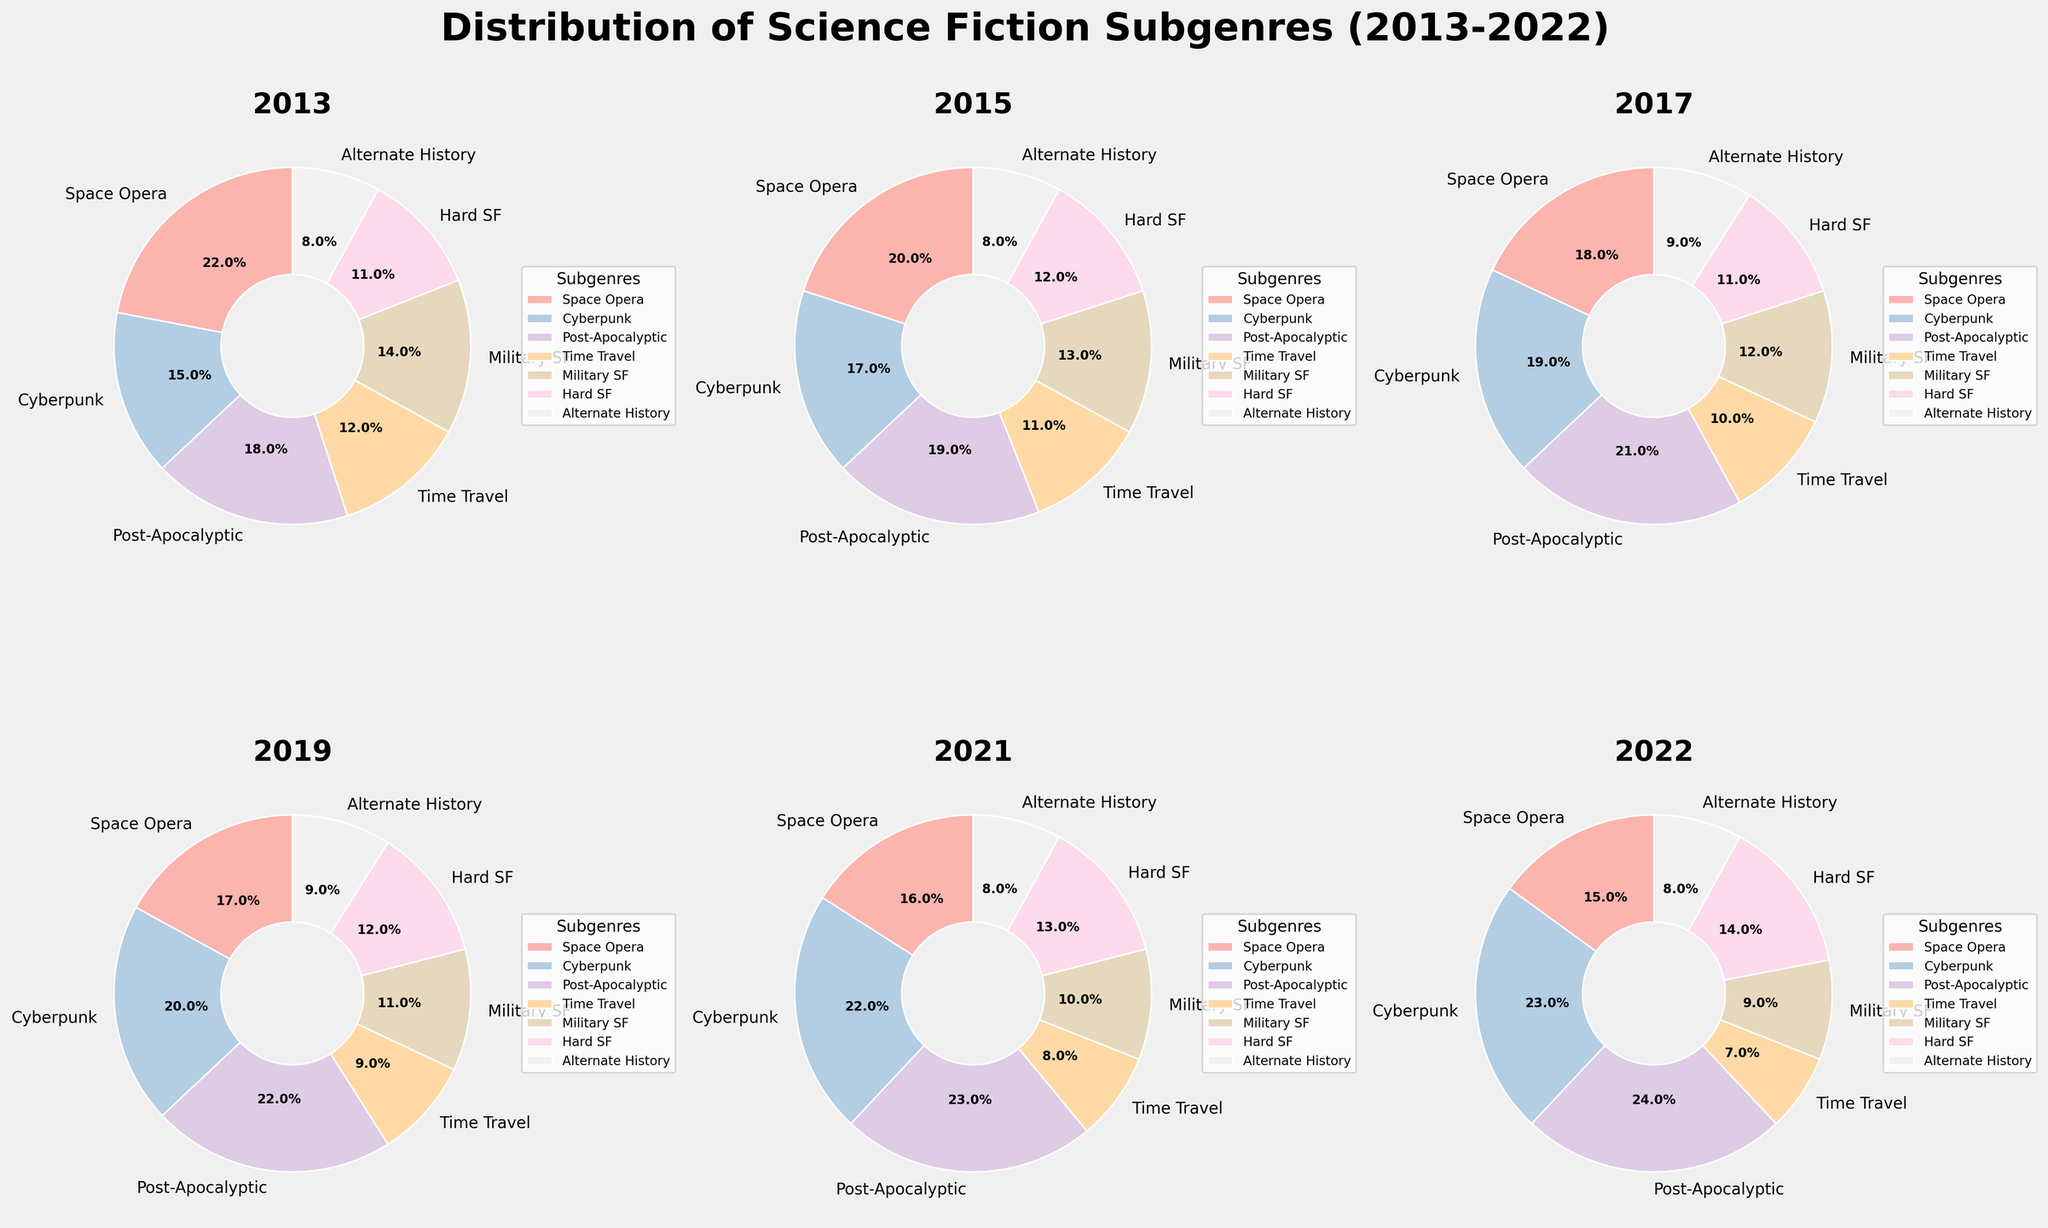What subgenre saw the highest percentage in 2022? To determine this, we look at the pie chart for the year 2022. The slice with the largest area and value is the subgenre we're looking for, which is Cyberpunk with 23%.
Answer: Cyberpunk with 23% Which subgenre's percentage increased the most from 2013 to 2022? To find this, identify the percentage of each subgenre in 2013 and 2022, and calculate the difference for each. The subgenre with the highest positive change is Cyberpunk (23% in 2022 - 15% in 2013 = 8%).
Answer: Cyberpunk with an 8% increase Did any subgenre remain at 8% throughout the given years? Inspect the pie charts for each year. Alternate History remains consistently at 8% each year: 2013, 2015, 2017, 2019, 2021, and 2022.
Answer: Alternate History Compare the trends of Space Opera and Post-Apocalyptic from 2013 to 2022. Check the percentages of Space Opera and Post-Apocalyptic for each given year: Space Opera decreases from 22% (2013) to 15% (2022), while Post-Apocalyptic increases from 18% (2013) to 24% (2022).
Answer: Space Opera decreases, Post-Apocalyptic increases Which year had the lowest percentage for Time Travel? Scan through the pie charts for each year focusing on Time Travel. The lowest percentage is 7% in 2022.
Answer: 2022 at 7% How many subgenres have a percentage of 12% or higher in any year? Count each instance where a subgenre reaches 12% or more across all years: Space Opera, Cyberpunk, Post-Apocalyptic, Military SF, Hard SF, and Time Travel.
Answer: 6 subgenres What is the combined percentage for Cyberpunk and Hard SF in 2021? Find the percentages for Cyberpunk (22%) and Hard SF (13%) in 2021 and sum them up: 22% + 13% = 35%.
Answer: 35% In which year did Post-Apocalyptic subgenre have its largest share, and what was it? Look at the percentages for Post-Apocalyptic from each pie chart. The largest percentage is in 2022 at 24%.
Answer: 2022 at 24% Has the Military SF subgenre's share increased or decreased from 2013 to 2022? Compare the percentages of Military SF for 2013 and 2022: 14% in 2013 and 9% in 2022, showing a decrease.
Answer: Decreased 